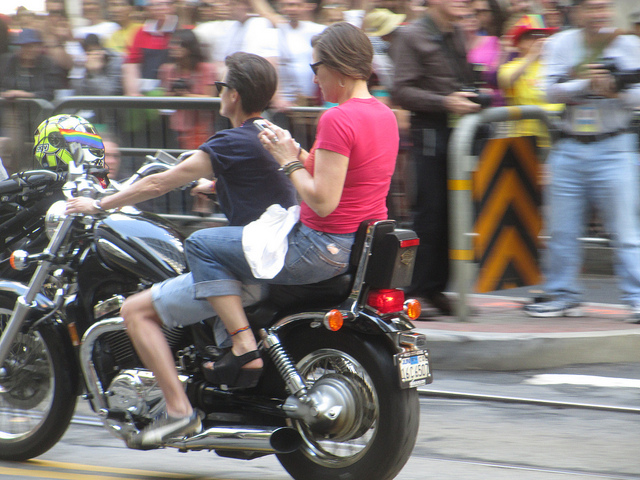<image>Where are they driving too in the motorcycle? I don't know where they are driving to on the motorcycle. It could be a parade or home. Where are they driving too in the motorcycle? I don't know where they are driving to in the motorcycle. It can be either forward, driving in parade, left, home, out to eat, or somewhere else. 